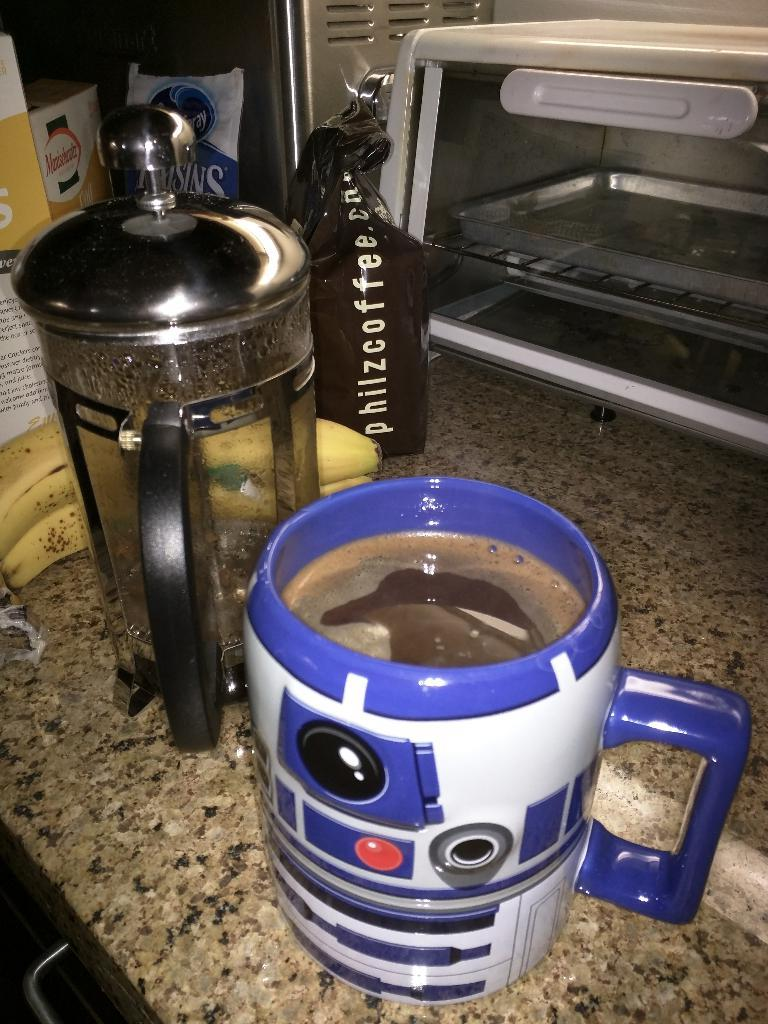<image>
Give a short and clear explanation of the subsequent image. A bag of phiz coffee sitting behind some bananas. 